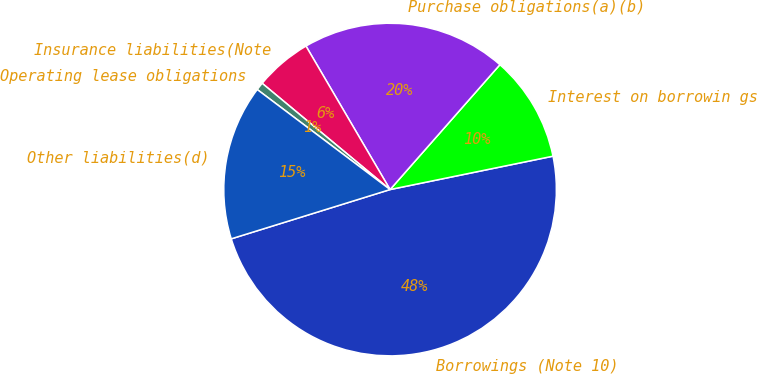Convert chart to OTSL. <chart><loc_0><loc_0><loc_500><loc_500><pie_chart><fcel>Borrowings (Note 10)<fcel>Interest on borrowin gs<fcel>Purchase obligations(a)(b)<fcel>Insurance liabilities(Note<fcel>Operating lease obligations<fcel>Other liabilities(d)<nl><fcel>48.43%<fcel>10.3%<fcel>19.92%<fcel>5.53%<fcel>0.76%<fcel>15.06%<nl></chart> 